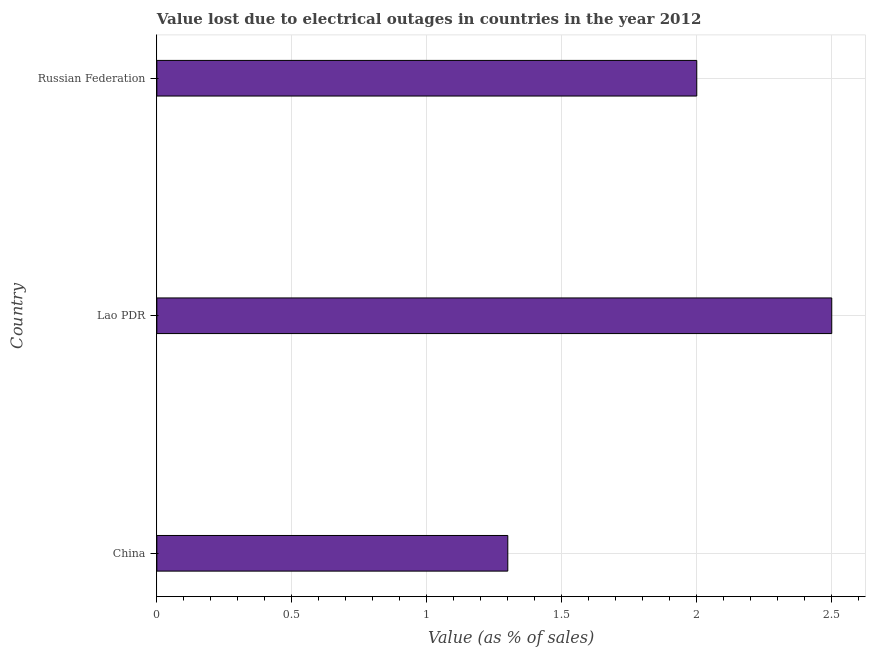Does the graph contain any zero values?
Ensure brevity in your answer.  No. Does the graph contain grids?
Provide a short and direct response. Yes. What is the title of the graph?
Offer a very short reply. Value lost due to electrical outages in countries in the year 2012. What is the label or title of the X-axis?
Make the answer very short. Value (as % of sales). What is the value lost due to electrical outages in Lao PDR?
Your answer should be very brief. 2.5. In which country was the value lost due to electrical outages maximum?
Your answer should be very brief. Lao PDR. In which country was the value lost due to electrical outages minimum?
Make the answer very short. China. What is the difference between the value lost due to electrical outages in China and Lao PDR?
Offer a very short reply. -1.2. What is the average value lost due to electrical outages per country?
Keep it short and to the point. 1.93. What is the median value lost due to electrical outages?
Provide a short and direct response. 2. What is the ratio of the value lost due to electrical outages in Lao PDR to that in Russian Federation?
Offer a very short reply. 1.25. Is the value lost due to electrical outages in Lao PDR less than that in Russian Federation?
Ensure brevity in your answer.  No. Is the sum of the value lost due to electrical outages in China and Lao PDR greater than the maximum value lost due to electrical outages across all countries?
Make the answer very short. Yes. Are all the bars in the graph horizontal?
Offer a terse response. Yes. How many countries are there in the graph?
Ensure brevity in your answer.  3. What is the Value (as % of sales) of Russian Federation?
Your answer should be very brief. 2. What is the difference between the Value (as % of sales) in China and Russian Federation?
Offer a very short reply. -0.7. What is the ratio of the Value (as % of sales) in China to that in Lao PDR?
Offer a very short reply. 0.52. What is the ratio of the Value (as % of sales) in China to that in Russian Federation?
Ensure brevity in your answer.  0.65. What is the ratio of the Value (as % of sales) in Lao PDR to that in Russian Federation?
Keep it short and to the point. 1.25. 